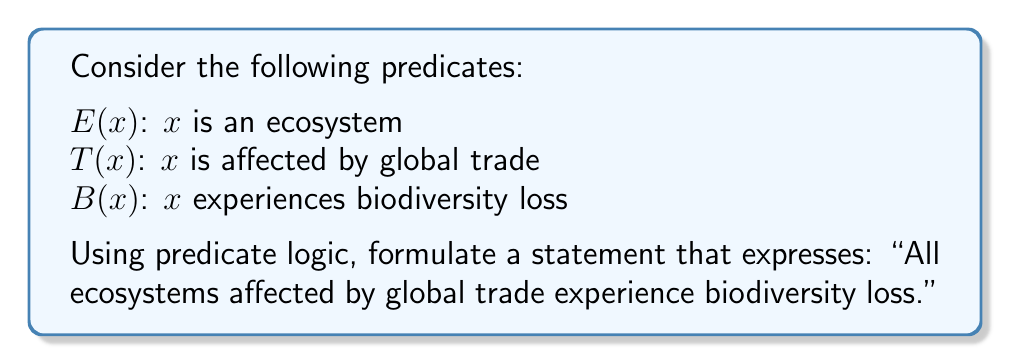Help me with this question. To formulate this statement using predicate logic, we need to combine the given predicates with appropriate quantifiers and logical connectives. Let's break it down step-by-step:

1. We want to make a statement about all ecosystems, so we'll start with the universal quantifier $\forall$ (for all).

2. We need to specify that we're talking about ecosystems, so we'll use the predicate $E(x)$.

3. The condition "affected by global trade" is represented by the predicate $T(x)$.

4. The consequence "experiences biodiversity loss" is represented by the predicate $B(x)$.

5. We need to connect these predicates using logical connectives. In this case, we'll use the implication symbol $\rightarrow$ to show that if an ecosystem is affected by global trade, then it experiences biodiversity loss.

6. Putting it all together, we get:

   $\forall x (E(x) \land T(x) \rightarrow B(x))$

This statement reads as: "For all $x$, if $x$ is an ecosystem and $x$ is affected by global trade, then $x$ experiences biodiversity loss."

This formulation accurately captures the given statement using predicate logic, allowing for a precise mathematical representation of the relationship between global trade and biodiversity loss in ecosystems.
Answer: $\forall x (E(x) \land T(x) \rightarrow B(x))$ 